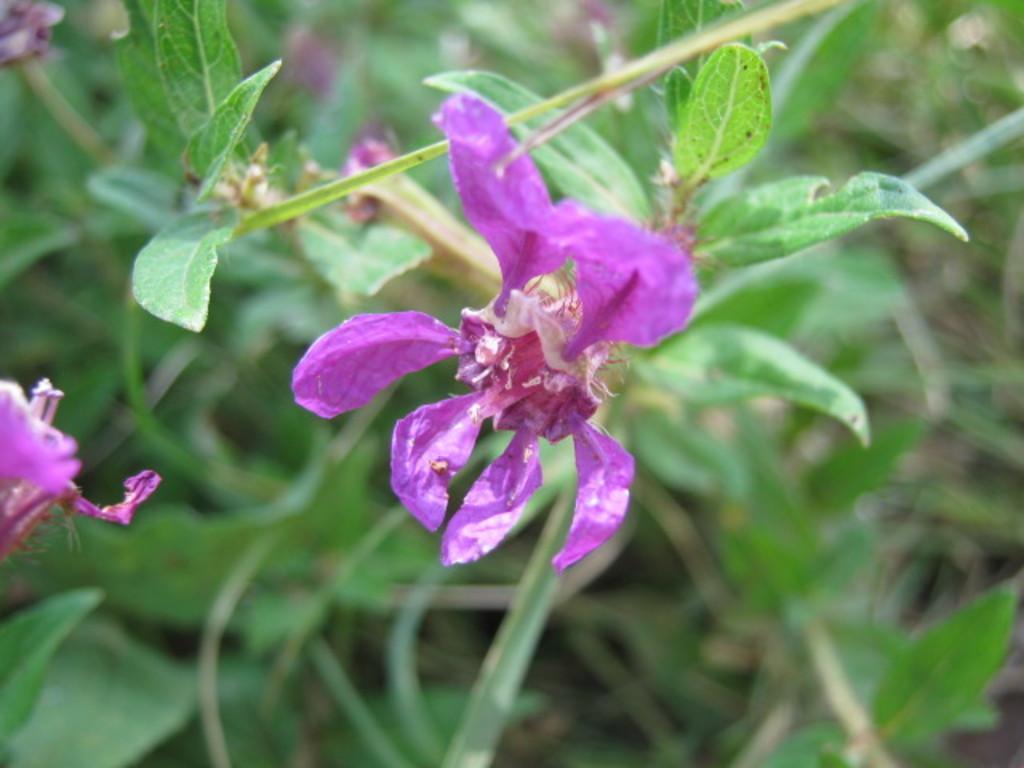Could you give a brief overview of what you see in this image? In the foreground of this image, there is a lavender color flower and in the background, there are plants. 